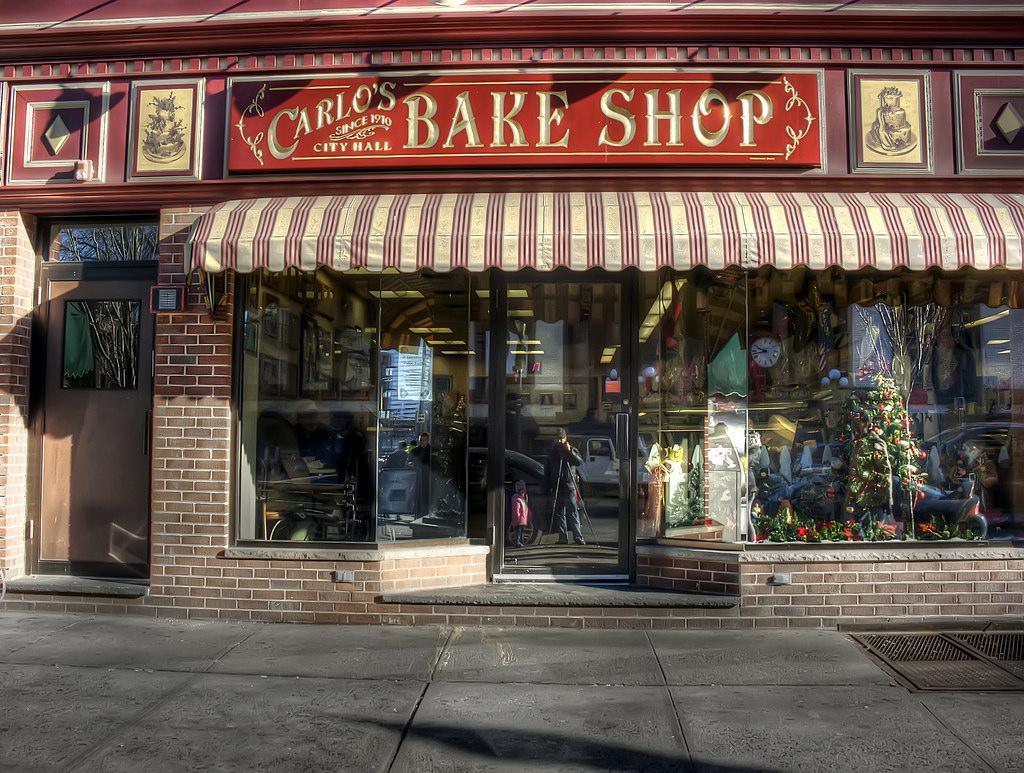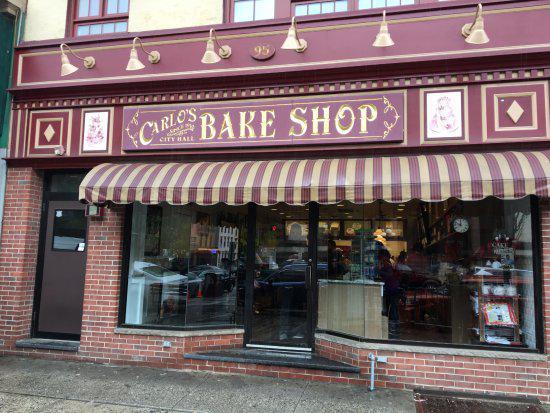The first image is the image on the left, the second image is the image on the right. Considering the images on both sides, is "There is at least one person standing outside the store in the image on the right." valid? Answer yes or no. No. 